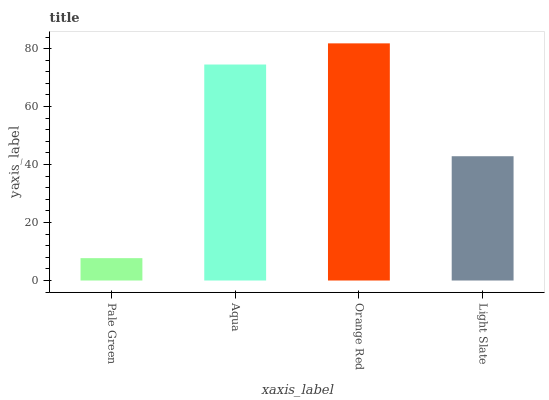Is Aqua the minimum?
Answer yes or no. No. Is Aqua the maximum?
Answer yes or no. No. Is Aqua greater than Pale Green?
Answer yes or no. Yes. Is Pale Green less than Aqua?
Answer yes or no. Yes. Is Pale Green greater than Aqua?
Answer yes or no. No. Is Aqua less than Pale Green?
Answer yes or no. No. Is Aqua the high median?
Answer yes or no. Yes. Is Light Slate the low median?
Answer yes or no. Yes. Is Orange Red the high median?
Answer yes or no. No. Is Pale Green the low median?
Answer yes or no. No. 